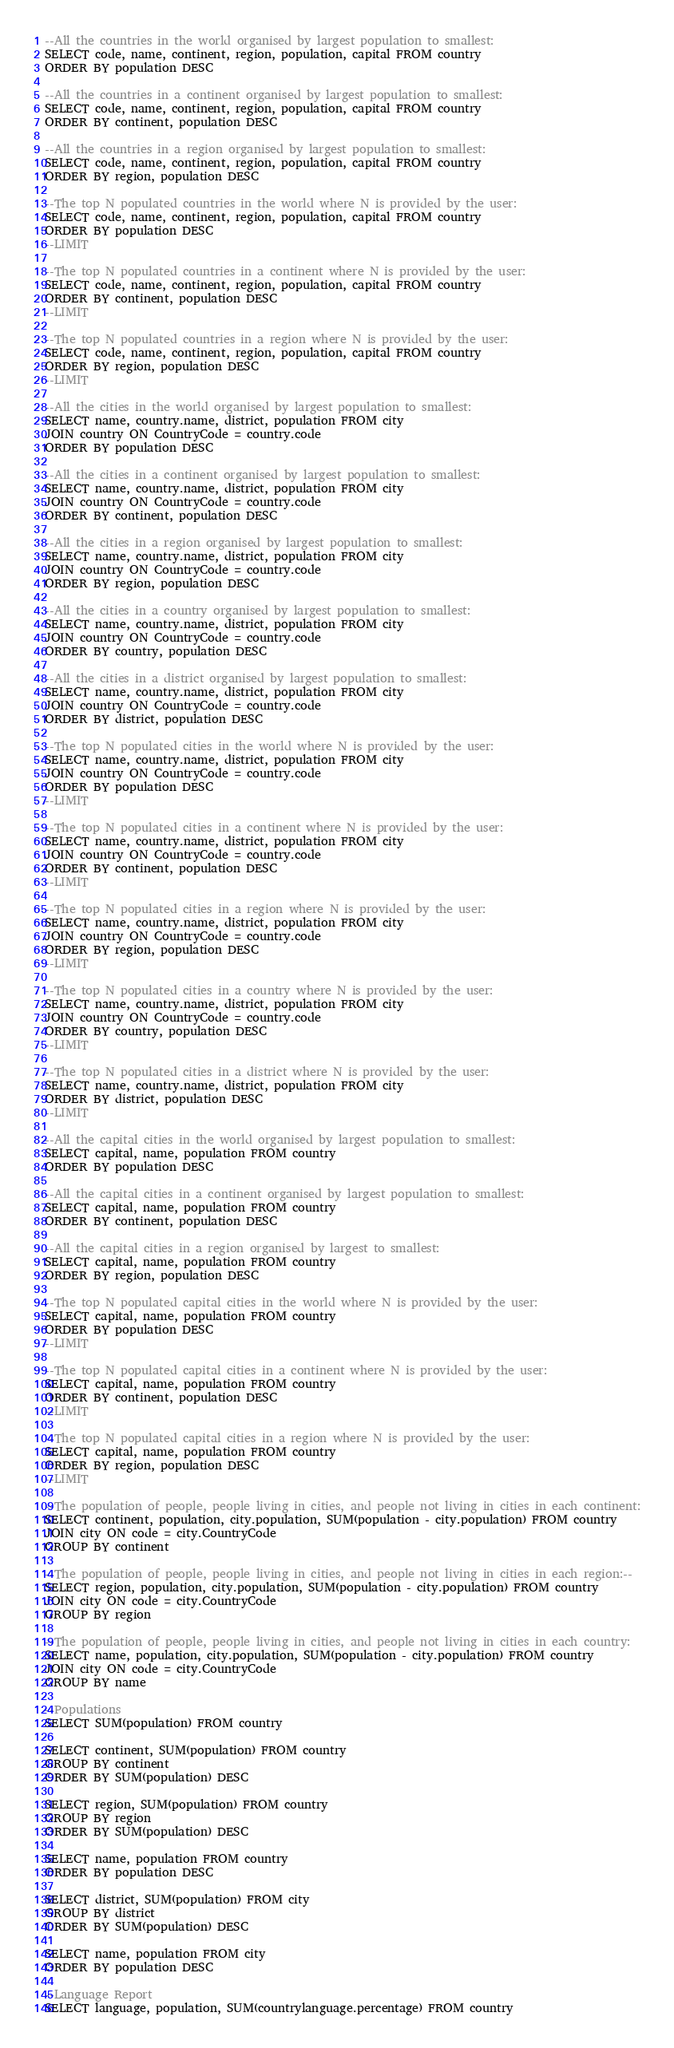Convert code to text. <code><loc_0><loc_0><loc_500><loc_500><_SQL_>--All the countries in the world organised by largest population to smallest:
SELECT code, name, continent, region, population, capital FROM country
ORDER BY population DESC

--All the countries in a continent organised by largest population to smallest:
SELECT code, name, continent, region, population, capital FROM country
ORDER BY continent, population DESC

--All the countries in a region organised by largest population to smallest:
SELECT code, name, continent, region, population, capital FROM country
ORDER BY region, population DESC

--The top N populated countries in the world where N is provided by the user:
SELECT code, name, continent, region, population, capital FROM country
ORDER BY population DESC
--LIMIT 

--The top N populated countries in a continent where N is provided by the user:
SELECT code, name, continent, region, population, capital FROM country
ORDER BY continent, population DESC
--LIMIT 

--The top N populated countries in a region where N is provided by the user:
SELECT code, name, continent, region, population, capital FROM country
ORDER BY region, population DESC
--LIMIT 

--All the cities in the world organised by largest population to smallest:
SELECT name, country.name, district, population FROM city
JOIN country ON CountryCode = country.code 
ORDER BY population DESC

--All the cities in a continent organised by largest population to smallest:
SELECT name, country.name, district, population FROM city
JOIN country ON CountryCode = country.code
ORDER BY continent, population DESC

--All the cities in a region organised by largest population to smallest:
SELECT name, country.name, district, population FROM city
JOIN country ON CountryCode = country.code
ORDER BY region, population DESC

--All the cities in a country organised by largest population to smallest:
SELECT name, country.name, district, population FROM city
JOIN country ON CountryCode = country.code 
ORDER BY country, population DESC

--All the cities in a district organised by largest population to smallest:
SELECT name, country.name, district, population FROM city
JOIN country ON CountryCode = country.code 
ORDER BY district, population DESC

--The top N populated cities in the world where N is provided by the user:
SELECT name, country.name, district, population FROM city
JOIN country ON CountryCode = country.code 
ORDER BY population DESC
--LIMIT 

--The top N populated cities in a continent where N is provided by the user:
SELECT name, country.name, district, population FROM city
JOIN country ON CountryCode = country.code 
ORDER BY continent, population DESC
--LIMIT 

--The top N populated cities in a region where N is provided by the user:
SELECT name, country.name, district, population FROM city
JOIN country ON CountryCode = country.code 
ORDER BY region, population DESC
--LIMIT 

--The top N populated cities in a country where N is provided by the user:
SELECT name, country.name, district, population FROM city
JOIN country ON CountryCode = country.code 
ORDER BY country, population DESC
--LIMIT 

--The top N populated cities in a district where N is provided by the user:
SELECT name, country.name, district, population FROM city
ORDER BY district, population DESC
--LIMIT 

--All the capital cities in the world organised by largest population to smallest:
SELECT capital, name, population FROM country
ORDER BY population DESC

--All the capital cities in a continent organised by largest population to smallest:
SELECT capital, name, population FROM country
ORDER BY continent, population DESC

--All the capital cities in a region organised by largest to smallest:
SELECT capital, name, population FROM country
ORDER BY region, population DESC

--The top N populated capital cities in the world where N is provided by the user:
SELECT capital, name, population FROM country
ORDER BY population DESC
--LIMIT 

--The top N populated capital cities in a continent where N is provided by the user:
SELECT capital, name, population FROM country
ORDER BY continent, population DESC
--LIMIT 

--The top N populated capital cities in a region where N is provided by the user:
SELECT capital, name, population FROM country
ORDER BY region, population DESC
--LIMIT 

--The population of people, people living in cities, and people not living in cities in each continent:
SELECT continent, population, city.population, SUM(population - city.population) FROM country
JOIN city ON code = city.CountryCode
GROUP BY continent

--The population of people, people living in cities, and people not living in cities in each region:--
SELECT region, population, city.population, SUM(population - city.population) FROM country
JOIN city ON code = city.CountryCode
GROUP BY region

--The population of people, people living in cities, and people not living in cities in each country:
SELECT name, population, city.population, SUM(population - city.population) FROM country
JOIN city ON code = city.CountryCode
GROUP BY name

--Populations
SELECT SUM(population) FROM country

SELECT continent, SUM(population) FROM country
GROUP BY continent
ORDER BY SUM(population) DESC

SELECT region, SUM(population) FROM country
GROUP BY region
ORDER BY SUM(population) DESC

SELECT name, population FROM country
ORDER BY population DESC

SELECT district, SUM(population) FROM city
GROUP BY district
ORDER BY SUM(population) DESC

SELECT name, population FROM city
ORDER BY population DESC

--Language Report
SELECT language, population, SUM(countrylanguage.percentage) FROM country</code> 